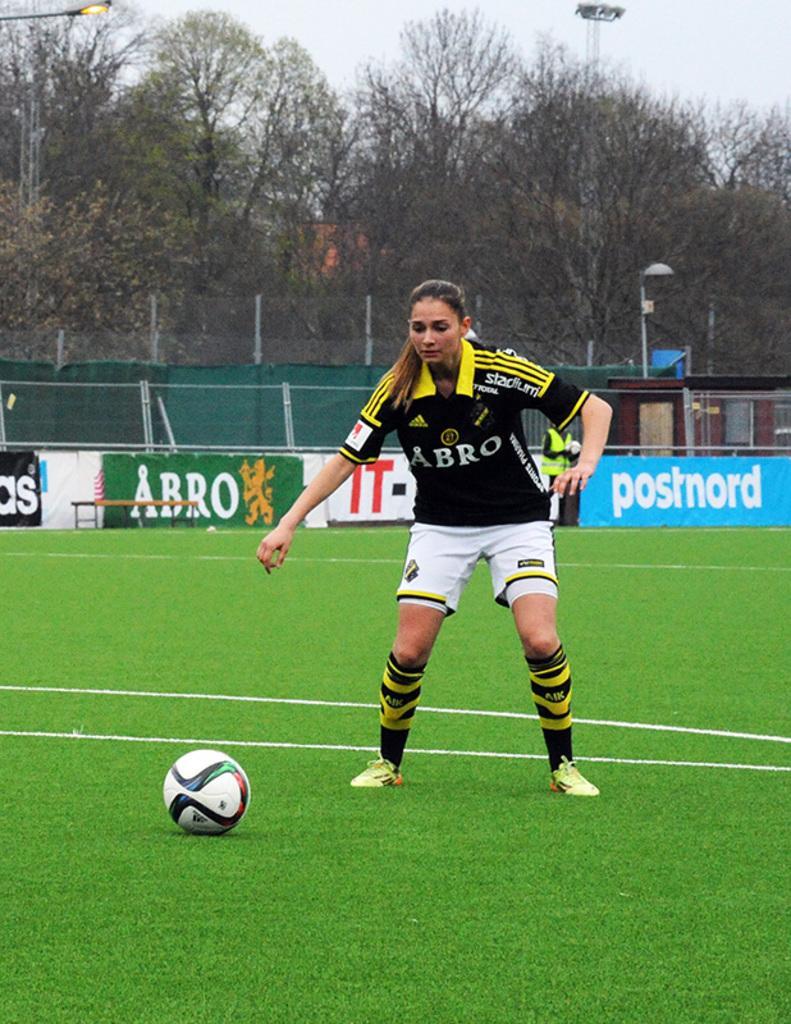Describe this image in one or two sentences. In this image, we can see people wearing sports dress and one of them is holding an object. In the background, there are trees, lights, poles, boards, a fence and tables. At the bottom, there is a ball on the ground. 